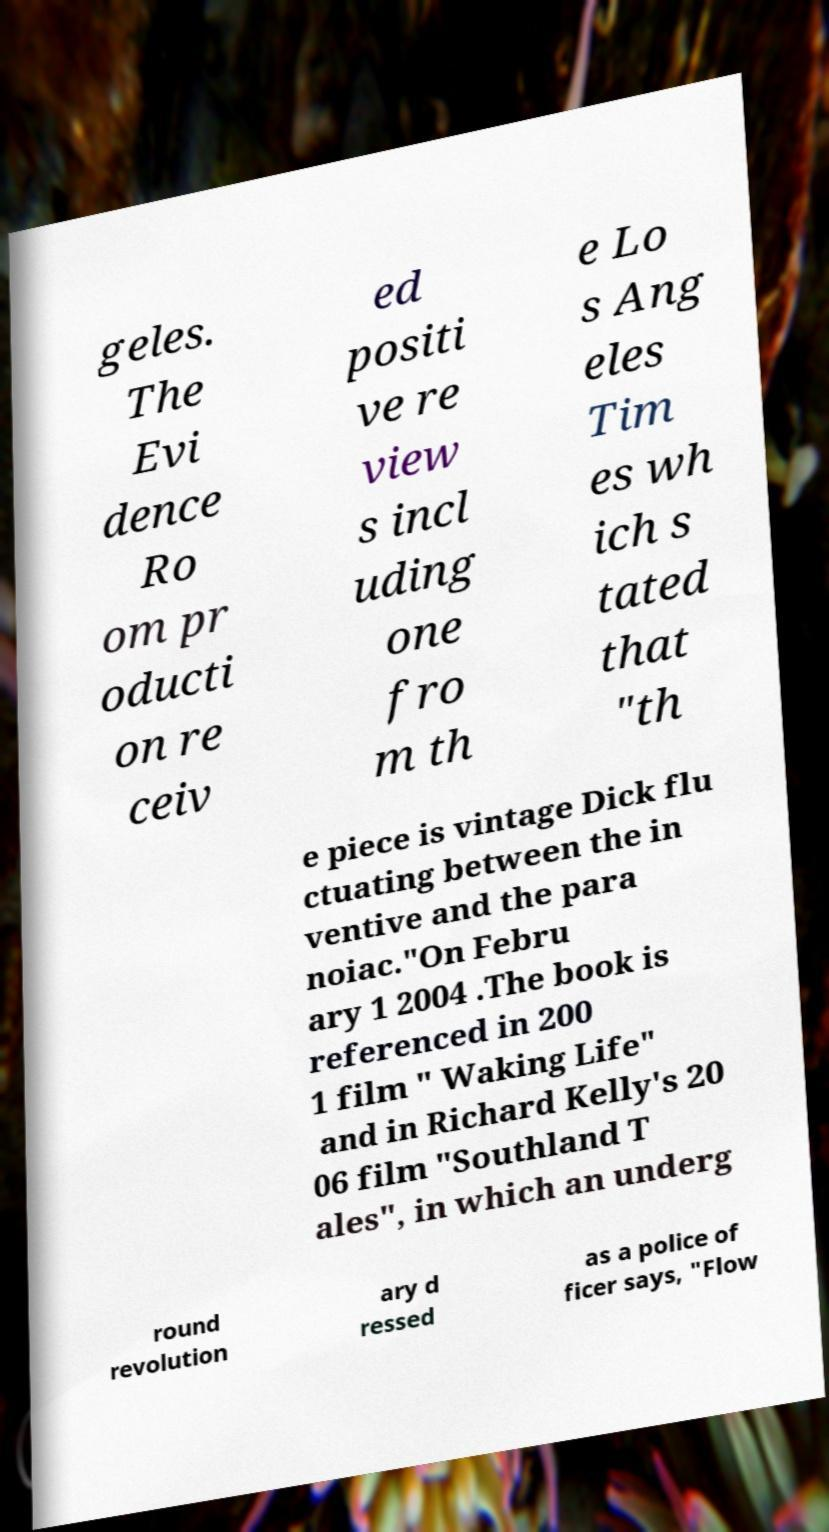Please read and relay the text visible in this image. What does it say? geles. The Evi dence Ro om pr oducti on re ceiv ed positi ve re view s incl uding one fro m th e Lo s Ang eles Tim es wh ich s tated that "th e piece is vintage Dick flu ctuating between the in ventive and the para noiac."On Febru ary 1 2004 .The book is referenced in 200 1 film " Waking Life" and in Richard Kelly's 20 06 film "Southland T ales", in which an underg round revolution ary d ressed as a police of ficer says, "Flow 